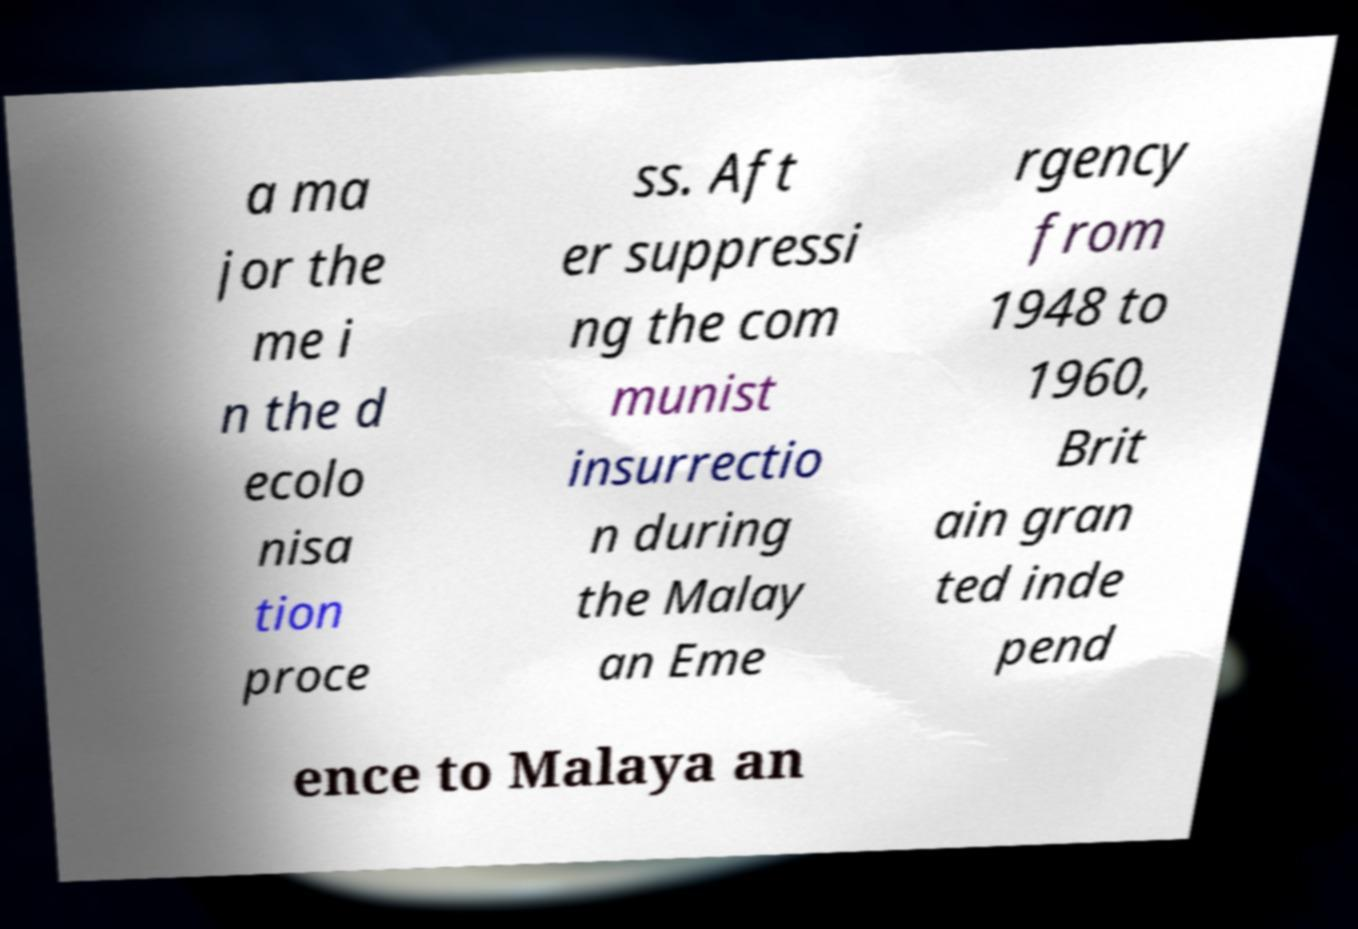Please read and relay the text visible in this image. What does it say? a ma jor the me i n the d ecolo nisa tion proce ss. Aft er suppressi ng the com munist insurrectio n during the Malay an Eme rgency from 1948 to 1960, Brit ain gran ted inde pend ence to Malaya an 